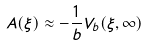<formula> <loc_0><loc_0><loc_500><loc_500>A ( \xi ) \approx - \frac { 1 } { b } V _ { b } ( \xi , \infty )</formula> 